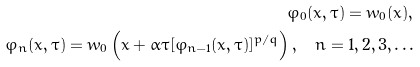<formula> <loc_0><loc_0><loc_500><loc_500>\varphi _ { 0 } ( x , \tau ) = w _ { 0 } ( x ) , \\ \varphi _ { n } ( x , \tau ) = w _ { 0 } \left ( x + \alpha \tau [ \varphi _ { n - 1 } ( x , \tau ) ] ^ { p / q } \right ) , \quad n = 1 , 2 , 3 , \dots</formula> 